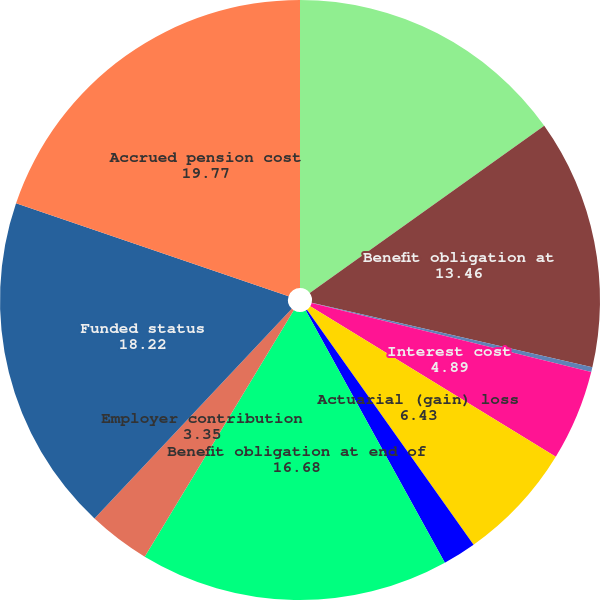<chart> <loc_0><loc_0><loc_500><loc_500><pie_chart><fcel>Accumulated benefit obligation<fcel>Benefit obligation at<fcel>Service cost<fcel>Interest cost<fcel>Actuarial (gain) loss<fcel>Benefits paid<fcel>Benefit obligation at end of<fcel>Employer contribution<fcel>Funded status<fcel>Accrued pension cost<nl><fcel>15.14%<fcel>13.46%<fcel>0.26%<fcel>4.89%<fcel>6.43%<fcel>1.8%<fcel>16.68%<fcel>3.35%<fcel>18.22%<fcel>19.77%<nl></chart> 